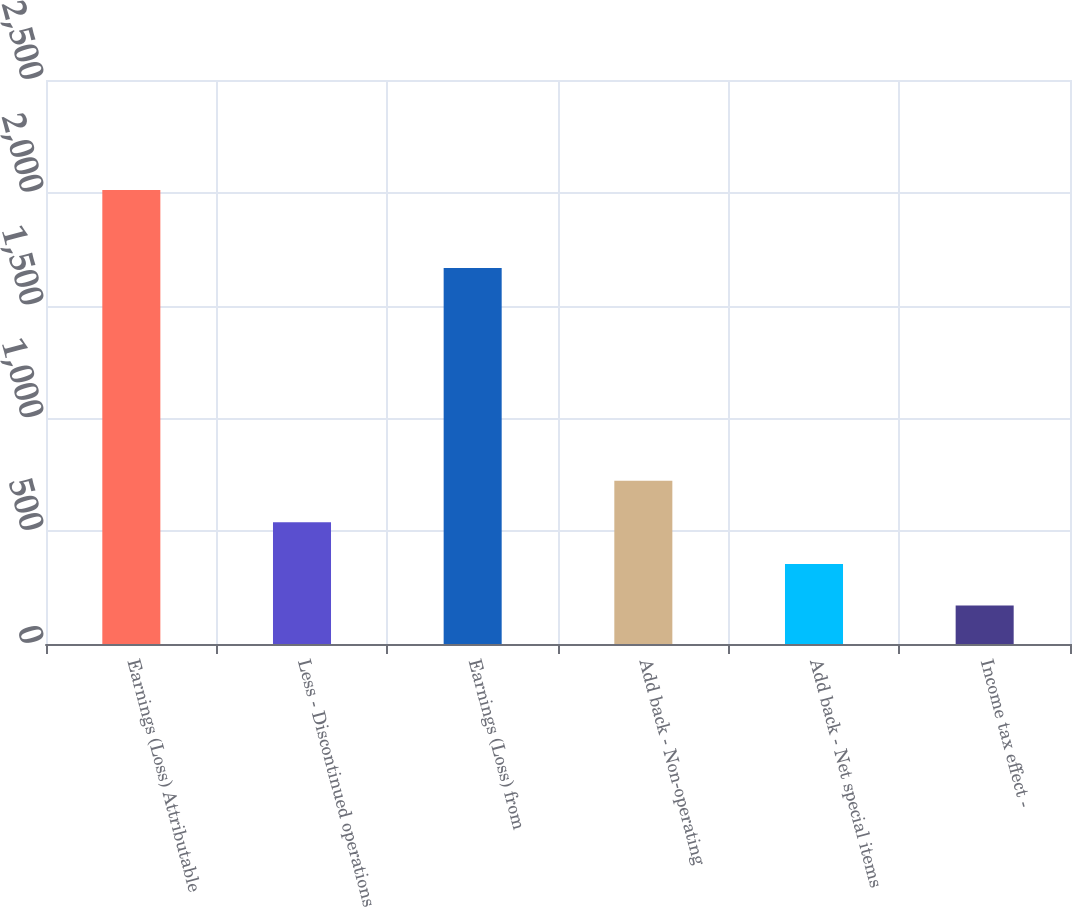Convert chart to OTSL. <chart><loc_0><loc_0><loc_500><loc_500><bar_chart><fcel>Earnings (Loss) Attributable<fcel>Less - Discontinued operations<fcel>Earnings (Loss) from<fcel>Add back - Non-operating<fcel>Add back - Net special items<fcel>Income tax effect -<nl><fcel>2012<fcel>539.2<fcel>1667<fcel>723.3<fcel>355.1<fcel>171<nl></chart> 